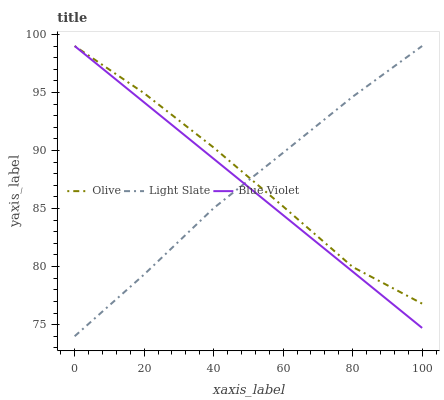Does Blue Violet have the minimum area under the curve?
Answer yes or no. Yes. Does Olive have the maximum area under the curve?
Answer yes or no. Yes. Does Light Slate have the minimum area under the curve?
Answer yes or no. No. Does Light Slate have the maximum area under the curve?
Answer yes or no. No. Is Blue Violet the smoothest?
Answer yes or no. Yes. Is Olive the roughest?
Answer yes or no. Yes. Is Light Slate the smoothest?
Answer yes or no. No. Is Light Slate the roughest?
Answer yes or no. No. Does Light Slate have the lowest value?
Answer yes or no. Yes. Does Blue Violet have the lowest value?
Answer yes or no. No. Does Blue Violet have the highest value?
Answer yes or no. Yes. Does Blue Violet intersect Light Slate?
Answer yes or no. Yes. Is Blue Violet less than Light Slate?
Answer yes or no. No. Is Blue Violet greater than Light Slate?
Answer yes or no. No. 